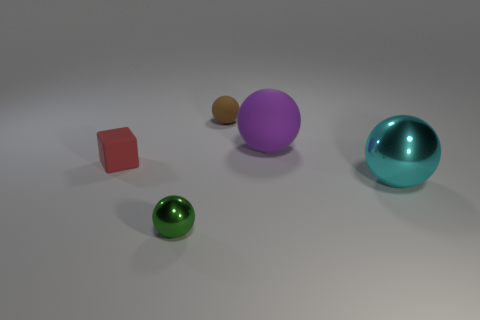There is a red matte thing; is its size the same as the sphere that is in front of the cyan shiny object?
Keep it short and to the point. Yes. How many shiny objects are big red objects or large purple spheres?
Offer a terse response. 0. There is a tiny brown thing; what shape is it?
Keep it short and to the point. Sphere. There is a rubber thing that is to the right of the sphere behind the large ball that is behind the red matte thing; how big is it?
Give a very brief answer. Large. How many other things are the same shape as the tiny green metal thing?
Your answer should be compact. 3. Does the metallic thing right of the small matte sphere have the same shape as the tiny object on the right side of the green thing?
Provide a short and direct response. Yes. How many balls are brown matte objects or purple rubber things?
Ensure brevity in your answer.  2. What material is the small ball behind the green shiny thing that is in front of the big ball behind the cyan ball?
Offer a very short reply. Rubber. What number of other things are there of the same size as the purple rubber object?
Provide a succinct answer. 1. Are there more things left of the cyan metallic thing than matte things?
Ensure brevity in your answer.  Yes. 